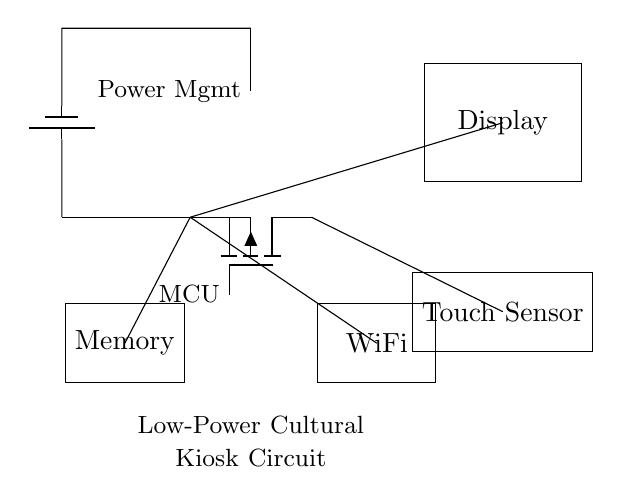What is the power management component in this circuit? The power management component is located at the top center of the circuit diagram, labeled and connected to the battery. It is responsible for regulating the power supply to the microcontroller and other components.
Answer: Power Management How many main components are visible in the circuit? By counting the distinct components shown in the diagram—Microcontroller, Display, Touch Sensor, Memory, and WiFi—the total number of main components can be identified. There are five components in total.
Answer: Five Which component is used for user interaction? The Touch Sensor is specifically designed for user interaction, allowing the user to engage directly with the kiosk by touching the screen to receive cultural information.
Answer: Touch Sensor What is the function of the WiFi module in this circuit? The WiFi module facilitates wireless communication, enabling the kiosk to connect to the internet and access external data. It is linked to the microcontroller for data transfer.
Answer: Wireless Communication What type of circuit is represented here? The circuit is a low-power microcontroller circuit designed for an interactive cultural information kiosk. This type is characterized by its efficiency and ability to engage users with minimal energy consumption.
Answer: Low-Power Microcontroller From which component does the display receive power? The display receives power from the power management component, which regulates the voltage supplied to it, ensuring it functions correctly. The connection is made directly from the power management node to the display.
Answer: Power Management 